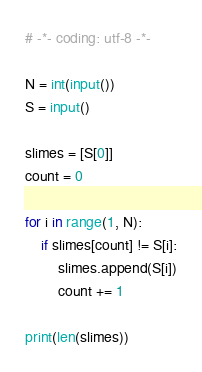Convert code to text. <code><loc_0><loc_0><loc_500><loc_500><_Python_># -*- coding: utf-8 -*-

N = int(input())
S = input()

slimes = [S[0]]
count = 0

for i in range(1, N):
    if slimes[count] != S[i]:
        slimes.append(S[i])
        count += 1

print(len(slimes))
</code> 